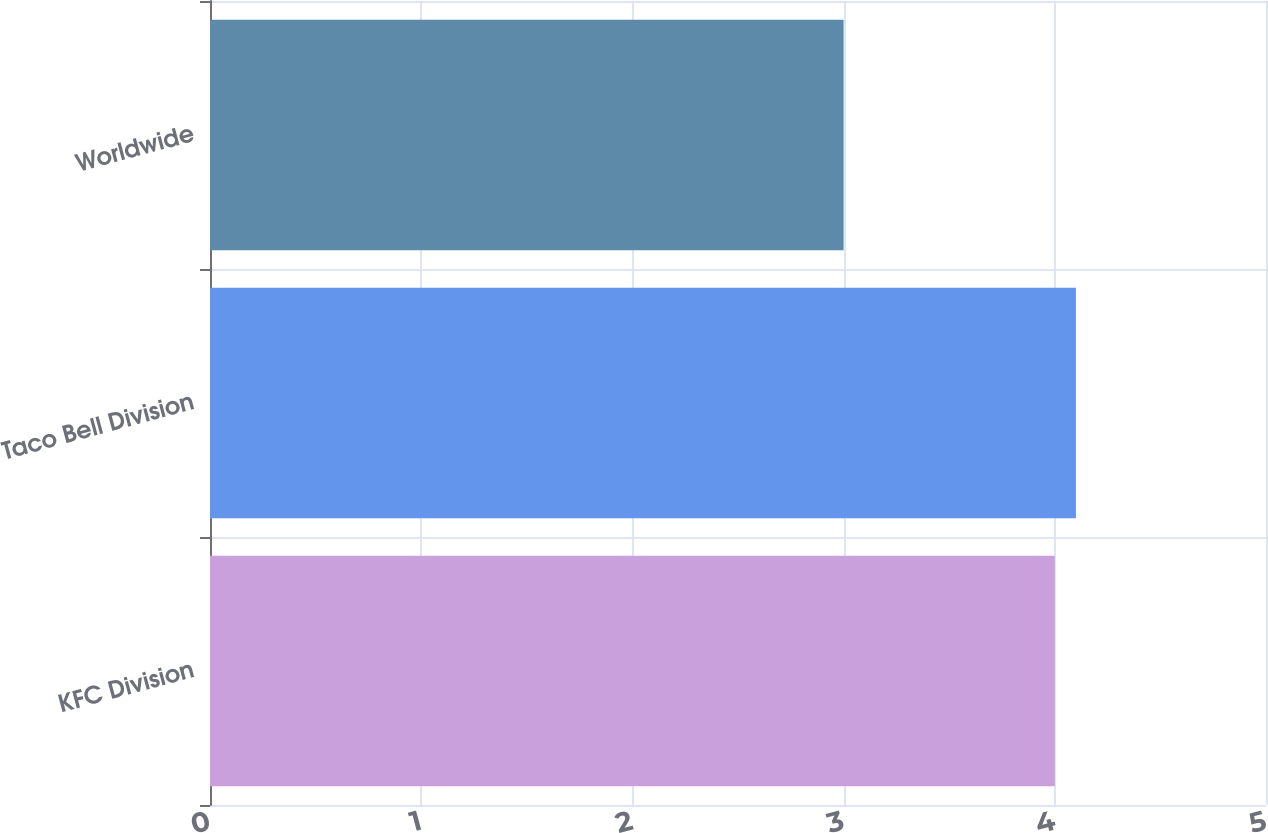<chart> <loc_0><loc_0><loc_500><loc_500><bar_chart><fcel>KFC Division<fcel>Taco Bell Division<fcel>Worldwide<nl><fcel>4<fcel>4.1<fcel>3<nl></chart> 